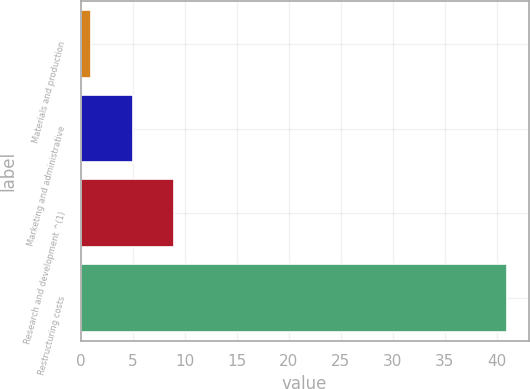Convert chart to OTSL. <chart><loc_0><loc_0><loc_500><loc_500><bar_chart><fcel>Materials and production<fcel>Marketing and administrative<fcel>Research and development ^(1)<fcel>Restructuring costs<nl><fcel>1<fcel>5<fcel>9<fcel>41<nl></chart> 